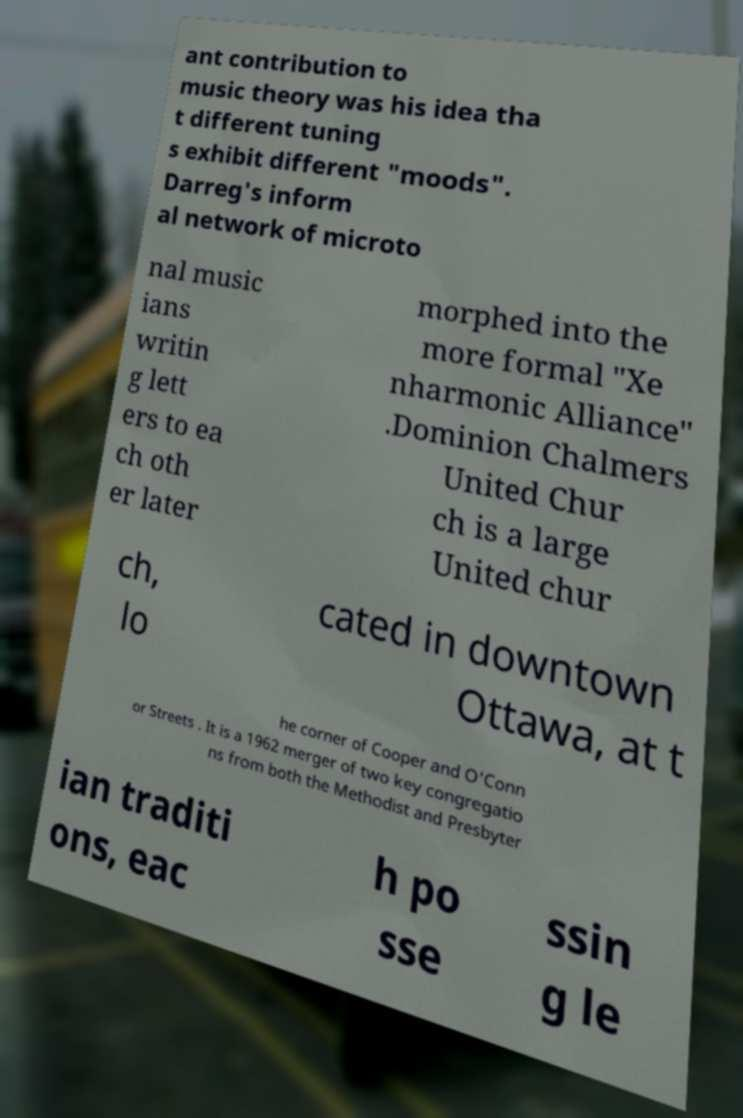Could you assist in decoding the text presented in this image and type it out clearly? ant contribution to music theory was his idea tha t different tuning s exhibit different "moods". Darreg's inform al network of microto nal music ians writin g lett ers to ea ch oth er later morphed into the more formal "Xe nharmonic Alliance" .Dominion Chalmers United Chur ch is a large United chur ch, lo cated in downtown Ottawa, at t he corner of Cooper and O'Conn or Streets . It is a 1962 merger of two key congregatio ns from both the Methodist and Presbyter ian traditi ons, eac h po sse ssin g le 